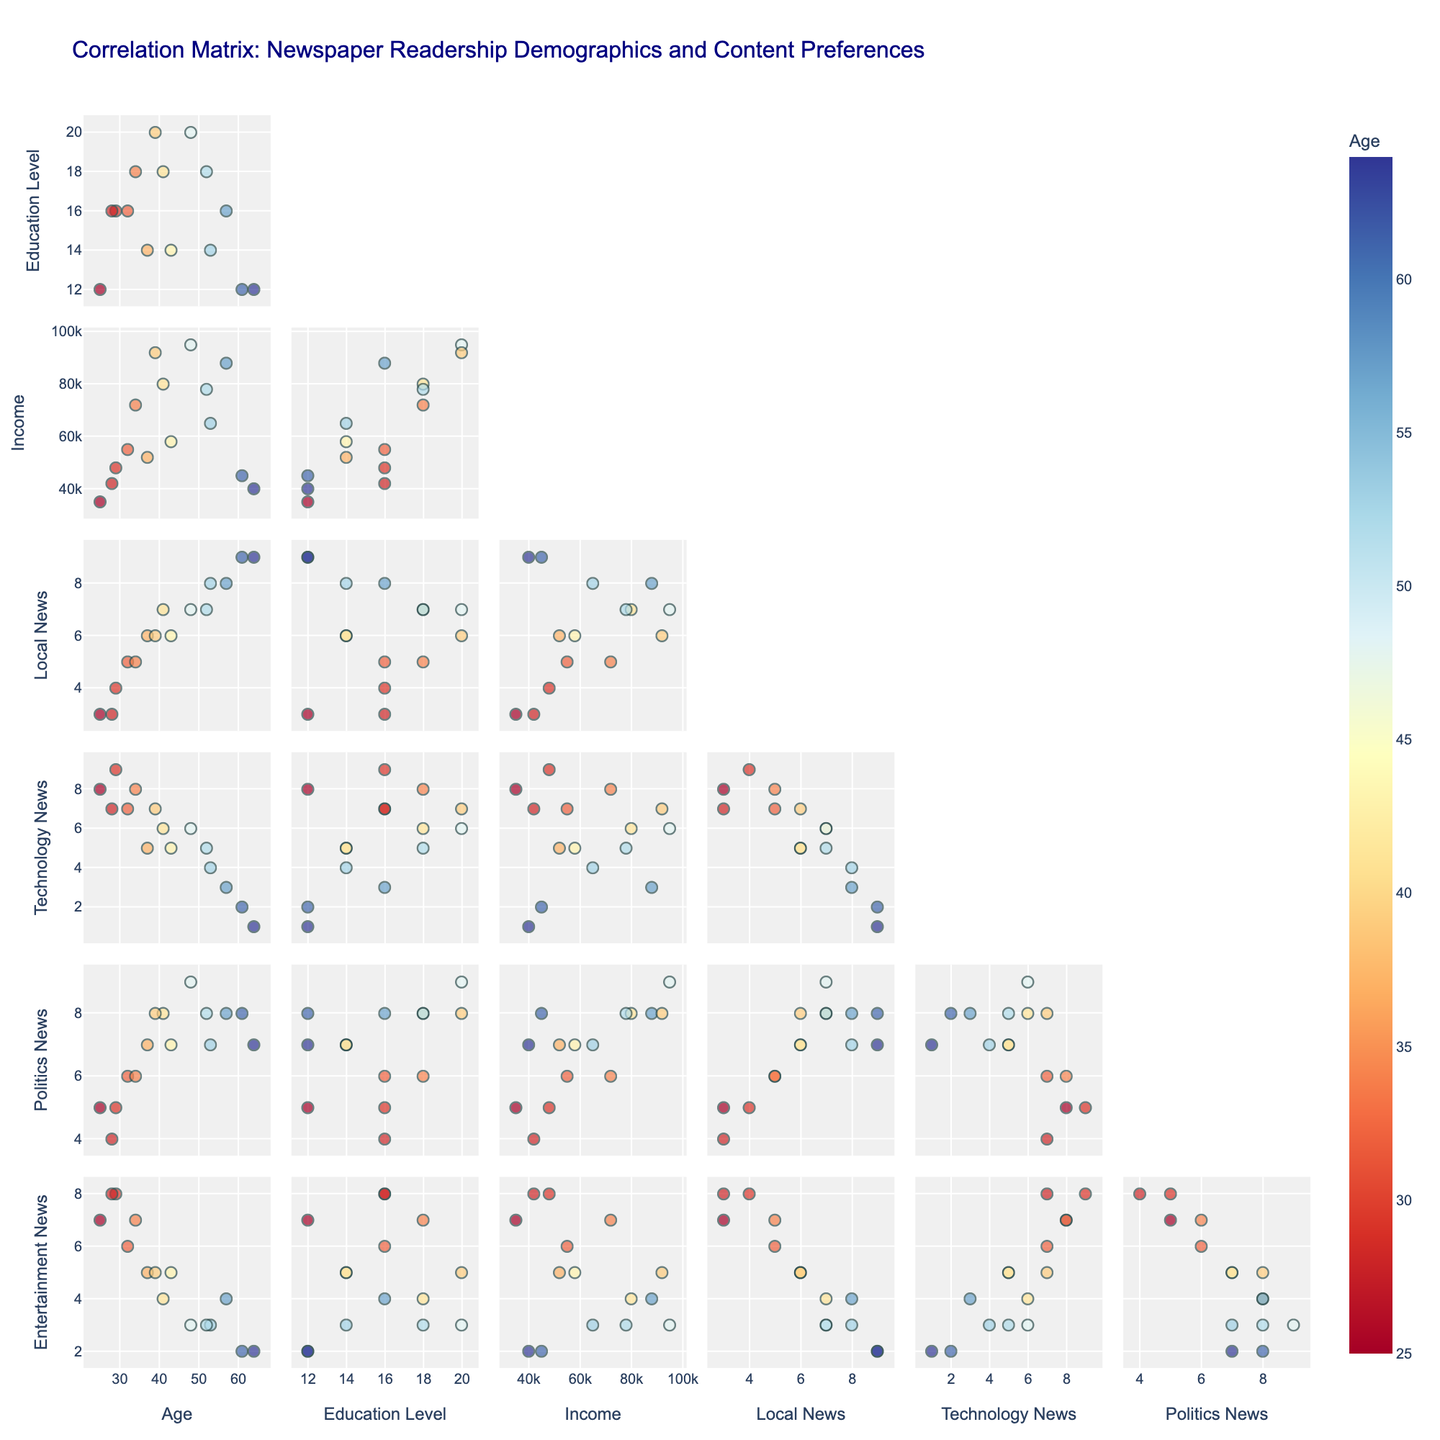How many different demographic features are analyzed in the scatter plot matrix? The scatter plot matrix includes dimensions such as Age, Education Level, Income, Local News Interest, Technology News Interest, Politics News Interest, and Entertainment News Interest. Counting these, there are a total of 7 demographic features analyzed.
Answer: 7 What can you deduce about the correlation between Age and Local News Interest from the scatterplot? To determine the correlation, we look at the scatter plot between Age and Local News Interest. There's a clustering of points that suggest a positive correlation; as Age increases, the Local News Interest generally seems to increase as well.
Answer: Positive correlation In the scatterplot matrix, which pair of features shows the highest value for the youngest age group? By examining the color-coded points for the youngest age group, the pair of features with the highest value can be seen in the Technology News Interest and Age plot. The youngest age group has a high Technology News Interest value.
Answer: Technology News Interest and Age Do higher levels of Education correlate with higher or lower interest in Politics News? To find this correlation, we need to look at the trend in the scatter plot between Education Level and Politics News Interest. It appears that as Education Level increases, Politics News Interest remains relatively high, indicating a positive or stable correlation.
Answer: Higher or stable correlation Is there more variability in Local News Interest or Technology News Interest among the readership? To determine variability, we compare the spread of data points in each respective scatter plot. The scatter plot for Local News Interest shows a wider spread of points compared to Technology News Interest, which is more clustered. Hence, there is more variability in Local News Interest.
Answer: Local News Interest What's the strongest negative correlation you can observe in the scatter matrix? To identify the strongest negative correlation, we look for a scatter plot where as one variable increases, the other decreases sharply. The scatter plot between Age and Technology News Interest shows a clear negative correlation: as Age increases, Technology News Interest decreases.
Answer: Age and Technology News Interest How does Entertainment News Interest vary with Income levels? By examining the scatter plot of Entertainment News Interest versus Income levels, we notice the points are somewhat scattered with a slight upward trend suggesting that Entertainment News Interest does not vary significantly with Income.
Answer: Slight positive trend Which feature appears to have the least correlation with Age? To find the feature with the least correlation, observe the scatter plots involving Age. The scatter plot between Age and Entertainment News Interest shows no clear pattern, indicating a very weak or no correlation.
Answer: Entertainment News Interest If we select the data point with the highest Income, what is their interest level in Politics News? By locating the data point with the highest Income in the scatter plot matrix, we see that it corresponds to an Income of 95,000, and checking its position in the Politics News Interest plot, it shows an interest level of 9.
Answer: 9 